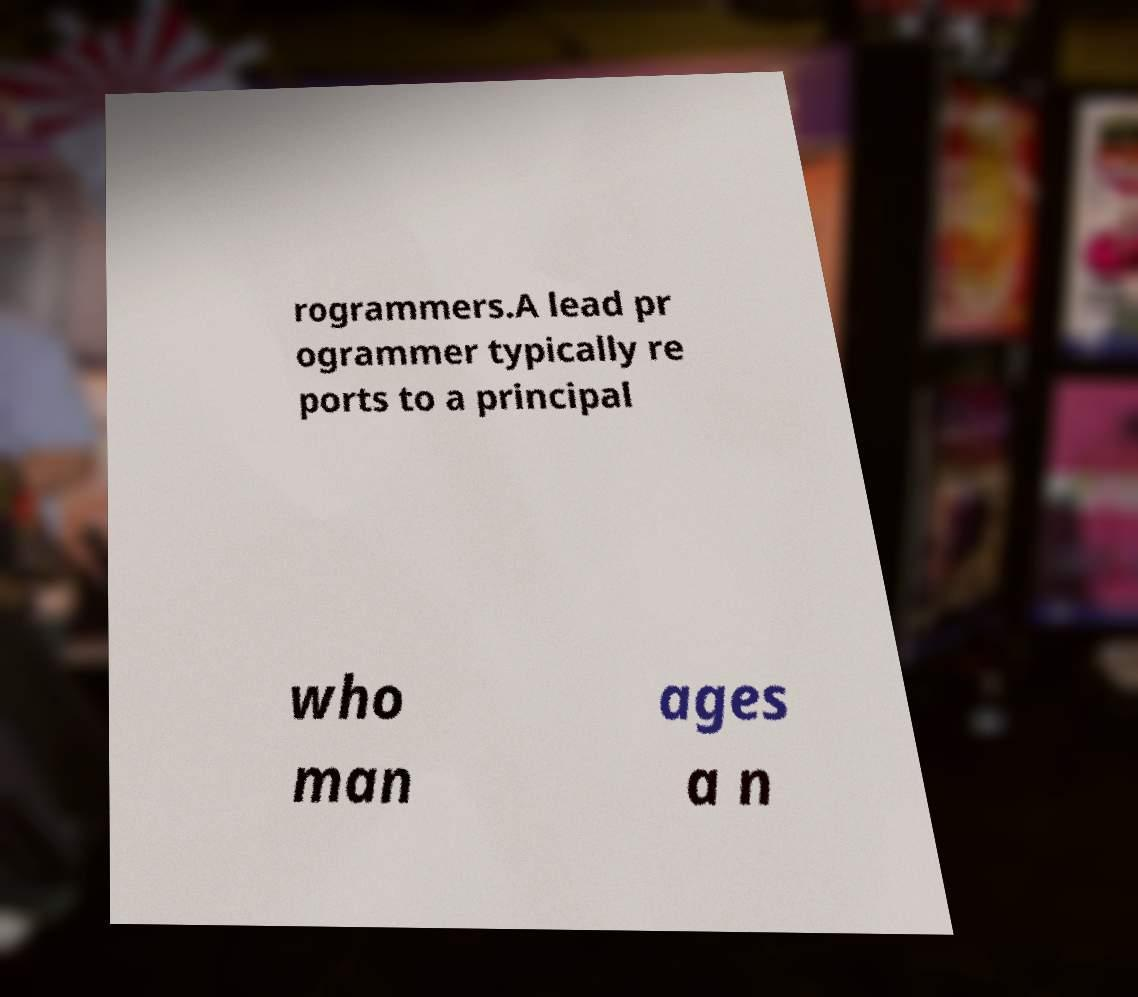Can you accurately transcribe the text from the provided image for me? rogrammers.A lead pr ogrammer typically re ports to a principal who man ages a n 